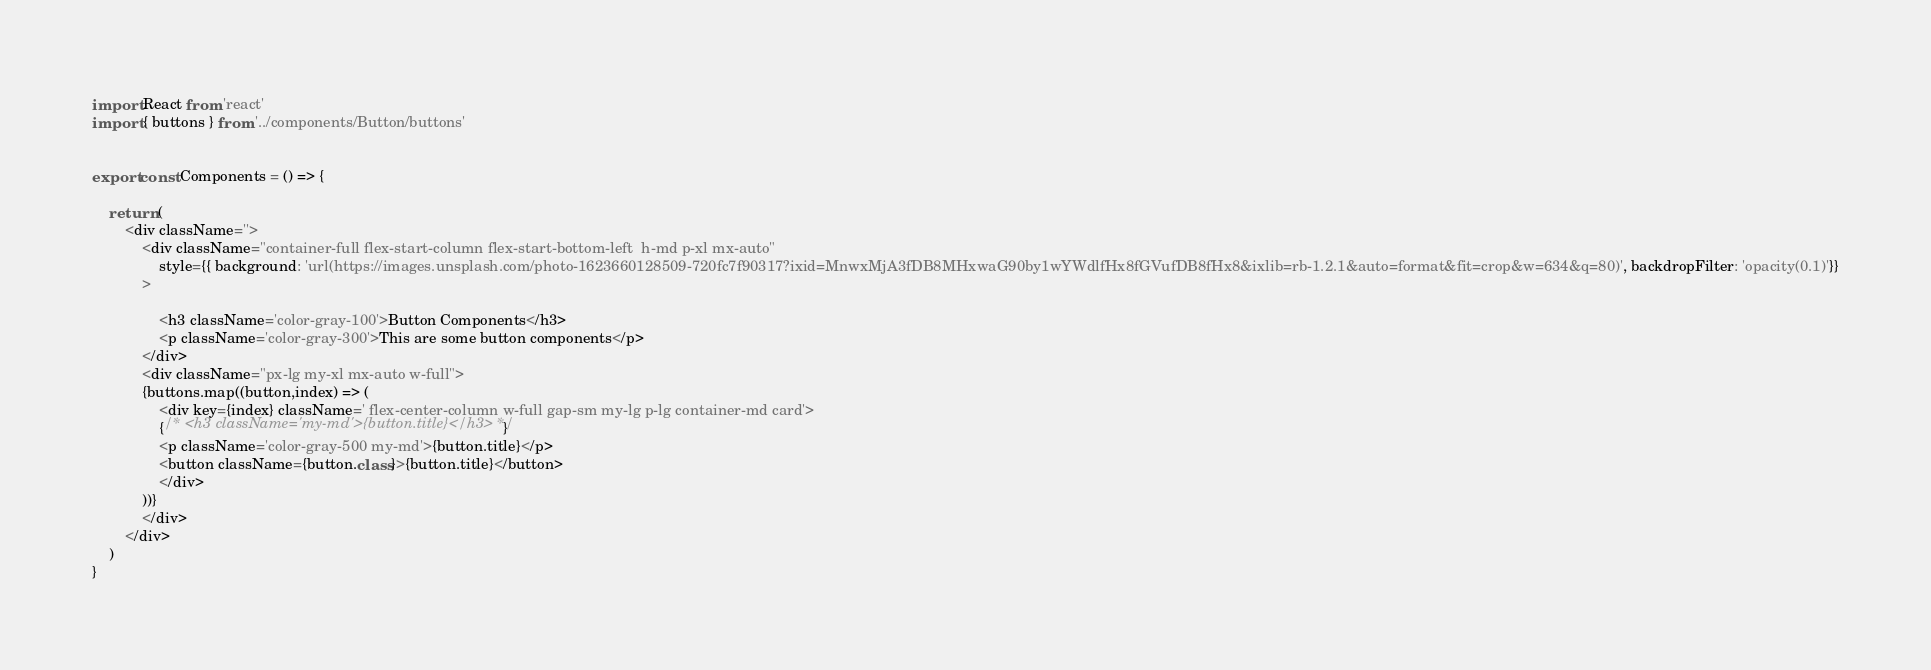Convert code to text. <code><loc_0><loc_0><loc_500><loc_500><_JavaScript_>import React from 'react'
import { buttons } from '../components/Button/buttons'


export const Components = () => {
   
    return (
        <div className=''>
            <div className="container-full flex-start-column flex-start-bottom-left  h-md p-xl mx-auto"
                style={{ background: 'url(https://images.unsplash.com/photo-1623660128509-720fc7f90317?ixid=MnwxMjA3fDB8MHxwaG90by1wYWdlfHx8fGVufDB8fHx8&ixlib=rb-1.2.1&auto=format&fit=crop&w=634&q=80)', backdropFilter: 'opacity(0.1)'}}
            >

                <h3 className='color-gray-100'>Button Components</h3>
                <p className='color-gray-300'>This are some button components</p>
            </div>
            <div className="px-lg my-xl mx-auto w-full">
            {buttons.map((button,index) => (
                <div key={index} className=' flex-center-column w-full gap-sm my-lg p-lg container-md card'>
                {/* <h3 className='my-md'>{button.title}</h3> */}
                <p className='color-gray-500 my-md'>{button.title}</p>
                <button className={button.class}>{button.title}</button>
                </div>
            ))}
            </div>
        </div>
    )
}
</code> 